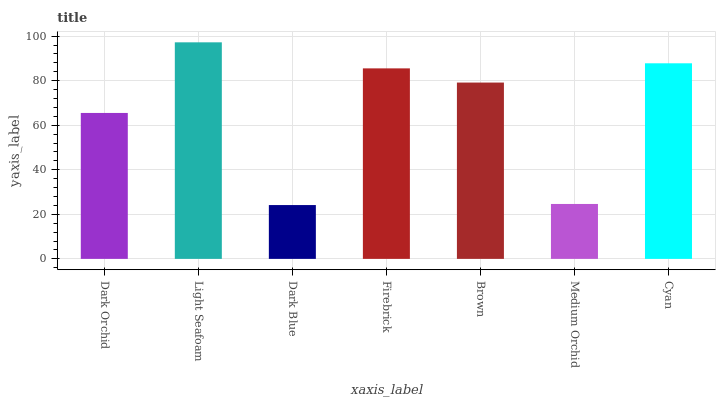Is Light Seafoam the minimum?
Answer yes or no. No. Is Dark Blue the maximum?
Answer yes or no. No. Is Light Seafoam greater than Dark Blue?
Answer yes or no. Yes. Is Dark Blue less than Light Seafoam?
Answer yes or no. Yes. Is Dark Blue greater than Light Seafoam?
Answer yes or no. No. Is Light Seafoam less than Dark Blue?
Answer yes or no. No. Is Brown the high median?
Answer yes or no. Yes. Is Brown the low median?
Answer yes or no. Yes. Is Light Seafoam the high median?
Answer yes or no. No. Is Firebrick the low median?
Answer yes or no. No. 